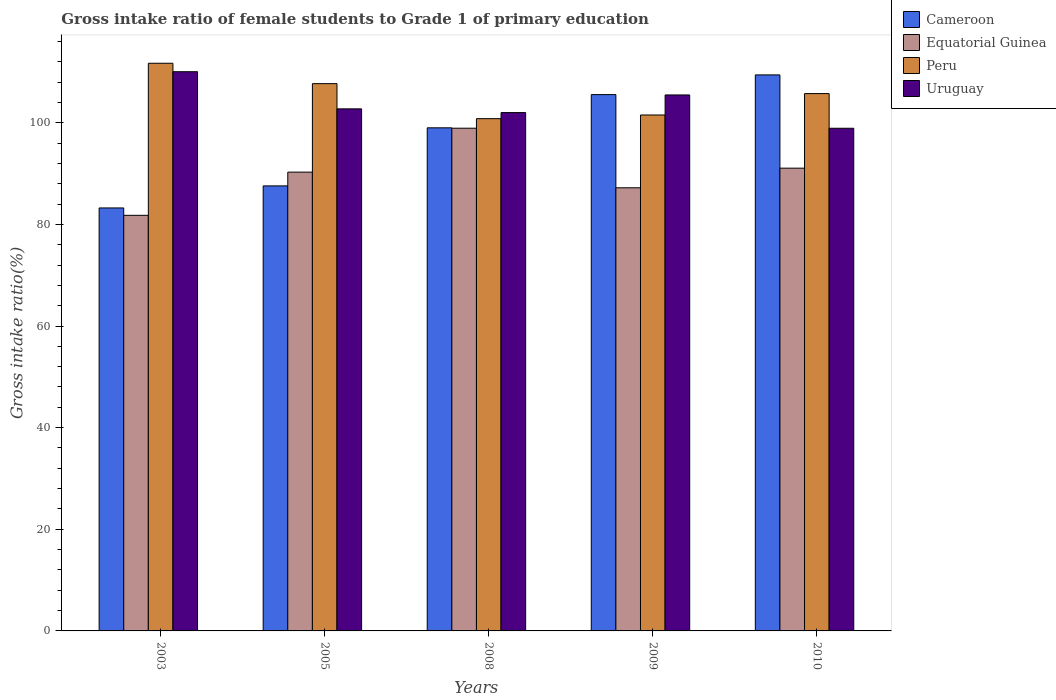How many different coloured bars are there?
Your answer should be compact. 4. How many groups of bars are there?
Provide a short and direct response. 5. Are the number of bars on each tick of the X-axis equal?
Ensure brevity in your answer.  Yes. What is the gross intake ratio in Peru in 2010?
Your response must be concise. 105.74. Across all years, what is the maximum gross intake ratio in Equatorial Guinea?
Offer a terse response. 98.92. Across all years, what is the minimum gross intake ratio in Uruguay?
Keep it short and to the point. 98.91. What is the total gross intake ratio in Uruguay in the graph?
Your response must be concise. 519.15. What is the difference between the gross intake ratio in Cameroon in 2009 and that in 2010?
Your answer should be compact. -3.88. What is the difference between the gross intake ratio in Equatorial Guinea in 2008 and the gross intake ratio in Peru in 2009?
Ensure brevity in your answer.  -2.6. What is the average gross intake ratio in Uruguay per year?
Offer a very short reply. 103.83. In the year 2003, what is the difference between the gross intake ratio in Cameroon and gross intake ratio in Peru?
Provide a short and direct response. -28.47. What is the ratio of the gross intake ratio in Uruguay in 2009 to that in 2010?
Provide a succinct answer. 1.07. What is the difference between the highest and the second highest gross intake ratio in Uruguay?
Offer a terse response. 4.57. What is the difference between the highest and the lowest gross intake ratio in Equatorial Guinea?
Provide a short and direct response. 17.14. Is it the case that in every year, the sum of the gross intake ratio in Uruguay and gross intake ratio in Peru is greater than the sum of gross intake ratio in Cameroon and gross intake ratio in Equatorial Guinea?
Offer a very short reply. Yes. What does the 3rd bar from the left in 2005 represents?
Provide a short and direct response. Peru. What does the 3rd bar from the right in 2005 represents?
Provide a succinct answer. Equatorial Guinea. Is it the case that in every year, the sum of the gross intake ratio in Equatorial Guinea and gross intake ratio in Cameroon is greater than the gross intake ratio in Peru?
Offer a very short reply. Yes. How many bars are there?
Offer a terse response. 20. Are all the bars in the graph horizontal?
Provide a short and direct response. No. Are the values on the major ticks of Y-axis written in scientific E-notation?
Make the answer very short. No. Does the graph contain grids?
Make the answer very short. No. How are the legend labels stacked?
Offer a very short reply. Vertical. What is the title of the graph?
Your response must be concise. Gross intake ratio of female students to Grade 1 of primary education. What is the label or title of the Y-axis?
Your answer should be compact. Gross intake ratio(%). What is the Gross intake ratio(%) in Cameroon in 2003?
Provide a succinct answer. 83.23. What is the Gross intake ratio(%) in Equatorial Guinea in 2003?
Make the answer very short. 81.78. What is the Gross intake ratio(%) in Peru in 2003?
Provide a short and direct response. 111.7. What is the Gross intake ratio(%) of Uruguay in 2003?
Your answer should be very brief. 110.04. What is the Gross intake ratio(%) in Cameroon in 2005?
Offer a terse response. 87.57. What is the Gross intake ratio(%) in Equatorial Guinea in 2005?
Your response must be concise. 90.28. What is the Gross intake ratio(%) of Peru in 2005?
Keep it short and to the point. 107.69. What is the Gross intake ratio(%) of Uruguay in 2005?
Provide a short and direct response. 102.73. What is the Gross intake ratio(%) in Cameroon in 2008?
Your response must be concise. 99. What is the Gross intake ratio(%) of Equatorial Guinea in 2008?
Offer a terse response. 98.92. What is the Gross intake ratio(%) of Peru in 2008?
Your answer should be compact. 100.8. What is the Gross intake ratio(%) of Uruguay in 2008?
Your response must be concise. 102. What is the Gross intake ratio(%) in Cameroon in 2009?
Your answer should be very brief. 105.54. What is the Gross intake ratio(%) of Equatorial Guinea in 2009?
Provide a succinct answer. 87.2. What is the Gross intake ratio(%) in Peru in 2009?
Give a very brief answer. 101.52. What is the Gross intake ratio(%) in Uruguay in 2009?
Keep it short and to the point. 105.47. What is the Gross intake ratio(%) of Cameroon in 2010?
Provide a succinct answer. 109.41. What is the Gross intake ratio(%) of Equatorial Guinea in 2010?
Offer a terse response. 91.06. What is the Gross intake ratio(%) of Peru in 2010?
Provide a succinct answer. 105.74. What is the Gross intake ratio(%) of Uruguay in 2010?
Keep it short and to the point. 98.91. Across all years, what is the maximum Gross intake ratio(%) of Cameroon?
Offer a very short reply. 109.41. Across all years, what is the maximum Gross intake ratio(%) of Equatorial Guinea?
Your answer should be very brief. 98.92. Across all years, what is the maximum Gross intake ratio(%) of Peru?
Offer a terse response. 111.7. Across all years, what is the maximum Gross intake ratio(%) in Uruguay?
Your answer should be very brief. 110.04. Across all years, what is the minimum Gross intake ratio(%) in Cameroon?
Your answer should be very brief. 83.23. Across all years, what is the minimum Gross intake ratio(%) in Equatorial Guinea?
Give a very brief answer. 81.78. Across all years, what is the minimum Gross intake ratio(%) in Peru?
Offer a very short reply. 100.8. Across all years, what is the minimum Gross intake ratio(%) in Uruguay?
Your answer should be very brief. 98.91. What is the total Gross intake ratio(%) of Cameroon in the graph?
Ensure brevity in your answer.  484.76. What is the total Gross intake ratio(%) in Equatorial Guinea in the graph?
Your answer should be very brief. 449.25. What is the total Gross intake ratio(%) of Peru in the graph?
Provide a succinct answer. 527.46. What is the total Gross intake ratio(%) in Uruguay in the graph?
Your answer should be very brief. 519.15. What is the difference between the Gross intake ratio(%) in Cameroon in 2003 and that in 2005?
Make the answer very short. -4.34. What is the difference between the Gross intake ratio(%) in Equatorial Guinea in 2003 and that in 2005?
Make the answer very short. -8.5. What is the difference between the Gross intake ratio(%) in Peru in 2003 and that in 2005?
Your answer should be compact. 4.01. What is the difference between the Gross intake ratio(%) in Uruguay in 2003 and that in 2005?
Keep it short and to the point. 7.31. What is the difference between the Gross intake ratio(%) of Cameroon in 2003 and that in 2008?
Provide a succinct answer. -15.77. What is the difference between the Gross intake ratio(%) of Equatorial Guinea in 2003 and that in 2008?
Offer a very short reply. -17.14. What is the difference between the Gross intake ratio(%) in Peru in 2003 and that in 2008?
Make the answer very short. 10.9. What is the difference between the Gross intake ratio(%) in Uruguay in 2003 and that in 2008?
Provide a succinct answer. 8.04. What is the difference between the Gross intake ratio(%) in Cameroon in 2003 and that in 2009?
Keep it short and to the point. -22.3. What is the difference between the Gross intake ratio(%) in Equatorial Guinea in 2003 and that in 2009?
Provide a succinct answer. -5.42. What is the difference between the Gross intake ratio(%) in Peru in 2003 and that in 2009?
Keep it short and to the point. 10.18. What is the difference between the Gross intake ratio(%) of Uruguay in 2003 and that in 2009?
Provide a succinct answer. 4.57. What is the difference between the Gross intake ratio(%) of Cameroon in 2003 and that in 2010?
Provide a short and direct response. -26.18. What is the difference between the Gross intake ratio(%) in Equatorial Guinea in 2003 and that in 2010?
Your response must be concise. -9.28. What is the difference between the Gross intake ratio(%) of Peru in 2003 and that in 2010?
Your answer should be compact. 5.97. What is the difference between the Gross intake ratio(%) in Uruguay in 2003 and that in 2010?
Your answer should be very brief. 11.13. What is the difference between the Gross intake ratio(%) in Cameroon in 2005 and that in 2008?
Your answer should be compact. -11.43. What is the difference between the Gross intake ratio(%) of Equatorial Guinea in 2005 and that in 2008?
Offer a terse response. -8.64. What is the difference between the Gross intake ratio(%) in Peru in 2005 and that in 2008?
Your answer should be very brief. 6.89. What is the difference between the Gross intake ratio(%) of Uruguay in 2005 and that in 2008?
Provide a succinct answer. 0.73. What is the difference between the Gross intake ratio(%) of Cameroon in 2005 and that in 2009?
Provide a succinct answer. -17.97. What is the difference between the Gross intake ratio(%) in Equatorial Guinea in 2005 and that in 2009?
Your response must be concise. 3.08. What is the difference between the Gross intake ratio(%) of Peru in 2005 and that in 2009?
Provide a short and direct response. 6.17. What is the difference between the Gross intake ratio(%) of Uruguay in 2005 and that in 2009?
Keep it short and to the point. -2.74. What is the difference between the Gross intake ratio(%) of Cameroon in 2005 and that in 2010?
Offer a very short reply. -21.84. What is the difference between the Gross intake ratio(%) in Equatorial Guinea in 2005 and that in 2010?
Give a very brief answer. -0.78. What is the difference between the Gross intake ratio(%) of Peru in 2005 and that in 2010?
Offer a terse response. 1.96. What is the difference between the Gross intake ratio(%) in Uruguay in 2005 and that in 2010?
Give a very brief answer. 3.82. What is the difference between the Gross intake ratio(%) of Cameroon in 2008 and that in 2009?
Make the answer very short. -6.54. What is the difference between the Gross intake ratio(%) in Equatorial Guinea in 2008 and that in 2009?
Make the answer very short. 11.72. What is the difference between the Gross intake ratio(%) in Peru in 2008 and that in 2009?
Keep it short and to the point. -0.72. What is the difference between the Gross intake ratio(%) in Uruguay in 2008 and that in 2009?
Provide a short and direct response. -3.47. What is the difference between the Gross intake ratio(%) in Cameroon in 2008 and that in 2010?
Offer a very short reply. -10.41. What is the difference between the Gross intake ratio(%) in Equatorial Guinea in 2008 and that in 2010?
Your response must be concise. 7.86. What is the difference between the Gross intake ratio(%) in Peru in 2008 and that in 2010?
Provide a succinct answer. -4.93. What is the difference between the Gross intake ratio(%) in Uruguay in 2008 and that in 2010?
Provide a short and direct response. 3.08. What is the difference between the Gross intake ratio(%) of Cameroon in 2009 and that in 2010?
Ensure brevity in your answer.  -3.88. What is the difference between the Gross intake ratio(%) of Equatorial Guinea in 2009 and that in 2010?
Make the answer very short. -3.86. What is the difference between the Gross intake ratio(%) of Peru in 2009 and that in 2010?
Make the answer very short. -4.21. What is the difference between the Gross intake ratio(%) in Uruguay in 2009 and that in 2010?
Keep it short and to the point. 6.56. What is the difference between the Gross intake ratio(%) of Cameroon in 2003 and the Gross intake ratio(%) of Equatorial Guinea in 2005?
Keep it short and to the point. -7.05. What is the difference between the Gross intake ratio(%) in Cameroon in 2003 and the Gross intake ratio(%) in Peru in 2005?
Your answer should be very brief. -24.46. What is the difference between the Gross intake ratio(%) of Cameroon in 2003 and the Gross intake ratio(%) of Uruguay in 2005?
Ensure brevity in your answer.  -19.5. What is the difference between the Gross intake ratio(%) of Equatorial Guinea in 2003 and the Gross intake ratio(%) of Peru in 2005?
Offer a terse response. -25.91. What is the difference between the Gross intake ratio(%) of Equatorial Guinea in 2003 and the Gross intake ratio(%) of Uruguay in 2005?
Give a very brief answer. -20.95. What is the difference between the Gross intake ratio(%) of Peru in 2003 and the Gross intake ratio(%) of Uruguay in 2005?
Your answer should be very brief. 8.97. What is the difference between the Gross intake ratio(%) in Cameroon in 2003 and the Gross intake ratio(%) in Equatorial Guinea in 2008?
Your answer should be very brief. -15.69. What is the difference between the Gross intake ratio(%) in Cameroon in 2003 and the Gross intake ratio(%) in Peru in 2008?
Your answer should be very brief. -17.57. What is the difference between the Gross intake ratio(%) in Cameroon in 2003 and the Gross intake ratio(%) in Uruguay in 2008?
Your answer should be very brief. -18.76. What is the difference between the Gross intake ratio(%) of Equatorial Guinea in 2003 and the Gross intake ratio(%) of Peru in 2008?
Ensure brevity in your answer.  -19.02. What is the difference between the Gross intake ratio(%) of Equatorial Guinea in 2003 and the Gross intake ratio(%) of Uruguay in 2008?
Provide a succinct answer. -20.22. What is the difference between the Gross intake ratio(%) in Peru in 2003 and the Gross intake ratio(%) in Uruguay in 2008?
Provide a succinct answer. 9.71. What is the difference between the Gross intake ratio(%) in Cameroon in 2003 and the Gross intake ratio(%) in Equatorial Guinea in 2009?
Keep it short and to the point. -3.97. What is the difference between the Gross intake ratio(%) of Cameroon in 2003 and the Gross intake ratio(%) of Peru in 2009?
Your response must be concise. -18.29. What is the difference between the Gross intake ratio(%) of Cameroon in 2003 and the Gross intake ratio(%) of Uruguay in 2009?
Offer a very short reply. -22.24. What is the difference between the Gross intake ratio(%) of Equatorial Guinea in 2003 and the Gross intake ratio(%) of Peru in 2009?
Your response must be concise. -19.74. What is the difference between the Gross intake ratio(%) of Equatorial Guinea in 2003 and the Gross intake ratio(%) of Uruguay in 2009?
Offer a very short reply. -23.69. What is the difference between the Gross intake ratio(%) of Peru in 2003 and the Gross intake ratio(%) of Uruguay in 2009?
Your answer should be compact. 6.23. What is the difference between the Gross intake ratio(%) in Cameroon in 2003 and the Gross intake ratio(%) in Equatorial Guinea in 2010?
Provide a short and direct response. -7.83. What is the difference between the Gross intake ratio(%) of Cameroon in 2003 and the Gross intake ratio(%) of Peru in 2010?
Your response must be concise. -22.5. What is the difference between the Gross intake ratio(%) of Cameroon in 2003 and the Gross intake ratio(%) of Uruguay in 2010?
Provide a succinct answer. -15.68. What is the difference between the Gross intake ratio(%) in Equatorial Guinea in 2003 and the Gross intake ratio(%) in Peru in 2010?
Ensure brevity in your answer.  -23.95. What is the difference between the Gross intake ratio(%) in Equatorial Guinea in 2003 and the Gross intake ratio(%) in Uruguay in 2010?
Provide a short and direct response. -17.13. What is the difference between the Gross intake ratio(%) of Peru in 2003 and the Gross intake ratio(%) of Uruguay in 2010?
Offer a very short reply. 12.79. What is the difference between the Gross intake ratio(%) in Cameroon in 2005 and the Gross intake ratio(%) in Equatorial Guinea in 2008?
Provide a succinct answer. -11.35. What is the difference between the Gross intake ratio(%) of Cameroon in 2005 and the Gross intake ratio(%) of Peru in 2008?
Provide a short and direct response. -13.23. What is the difference between the Gross intake ratio(%) in Cameroon in 2005 and the Gross intake ratio(%) in Uruguay in 2008?
Offer a very short reply. -14.43. What is the difference between the Gross intake ratio(%) in Equatorial Guinea in 2005 and the Gross intake ratio(%) in Peru in 2008?
Give a very brief answer. -10.52. What is the difference between the Gross intake ratio(%) in Equatorial Guinea in 2005 and the Gross intake ratio(%) in Uruguay in 2008?
Your answer should be very brief. -11.72. What is the difference between the Gross intake ratio(%) of Peru in 2005 and the Gross intake ratio(%) of Uruguay in 2008?
Keep it short and to the point. 5.7. What is the difference between the Gross intake ratio(%) in Cameroon in 2005 and the Gross intake ratio(%) in Equatorial Guinea in 2009?
Your response must be concise. 0.37. What is the difference between the Gross intake ratio(%) of Cameroon in 2005 and the Gross intake ratio(%) of Peru in 2009?
Provide a succinct answer. -13.95. What is the difference between the Gross intake ratio(%) of Cameroon in 2005 and the Gross intake ratio(%) of Uruguay in 2009?
Your answer should be very brief. -17.9. What is the difference between the Gross intake ratio(%) in Equatorial Guinea in 2005 and the Gross intake ratio(%) in Peru in 2009?
Your answer should be compact. -11.24. What is the difference between the Gross intake ratio(%) of Equatorial Guinea in 2005 and the Gross intake ratio(%) of Uruguay in 2009?
Offer a terse response. -15.19. What is the difference between the Gross intake ratio(%) of Peru in 2005 and the Gross intake ratio(%) of Uruguay in 2009?
Your response must be concise. 2.22. What is the difference between the Gross intake ratio(%) of Cameroon in 2005 and the Gross intake ratio(%) of Equatorial Guinea in 2010?
Give a very brief answer. -3.49. What is the difference between the Gross intake ratio(%) in Cameroon in 2005 and the Gross intake ratio(%) in Peru in 2010?
Offer a terse response. -18.16. What is the difference between the Gross intake ratio(%) of Cameroon in 2005 and the Gross intake ratio(%) of Uruguay in 2010?
Provide a short and direct response. -11.34. What is the difference between the Gross intake ratio(%) of Equatorial Guinea in 2005 and the Gross intake ratio(%) of Peru in 2010?
Offer a very short reply. -15.46. What is the difference between the Gross intake ratio(%) in Equatorial Guinea in 2005 and the Gross intake ratio(%) in Uruguay in 2010?
Provide a succinct answer. -8.63. What is the difference between the Gross intake ratio(%) of Peru in 2005 and the Gross intake ratio(%) of Uruguay in 2010?
Your answer should be compact. 8.78. What is the difference between the Gross intake ratio(%) of Cameroon in 2008 and the Gross intake ratio(%) of Equatorial Guinea in 2009?
Your response must be concise. 11.8. What is the difference between the Gross intake ratio(%) in Cameroon in 2008 and the Gross intake ratio(%) in Peru in 2009?
Give a very brief answer. -2.52. What is the difference between the Gross intake ratio(%) of Cameroon in 2008 and the Gross intake ratio(%) of Uruguay in 2009?
Make the answer very short. -6.47. What is the difference between the Gross intake ratio(%) in Equatorial Guinea in 2008 and the Gross intake ratio(%) in Peru in 2009?
Give a very brief answer. -2.6. What is the difference between the Gross intake ratio(%) of Equatorial Guinea in 2008 and the Gross intake ratio(%) of Uruguay in 2009?
Give a very brief answer. -6.55. What is the difference between the Gross intake ratio(%) in Peru in 2008 and the Gross intake ratio(%) in Uruguay in 2009?
Make the answer very short. -4.67. What is the difference between the Gross intake ratio(%) of Cameroon in 2008 and the Gross intake ratio(%) of Equatorial Guinea in 2010?
Your response must be concise. 7.94. What is the difference between the Gross intake ratio(%) in Cameroon in 2008 and the Gross intake ratio(%) in Peru in 2010?
Give a very brief answer. -6.73. What is the difference between the Gross intake ratio(%) in Cameroon in 2008 and the Gross intake ratio(%) in Uruguay in 2010?
Keep it short and to the point. 0.09. What is the difference between the Gross intake ratio(%) in Equatorial Guinea in 2008 and the Gross intake ratio(%) in Peru in 2010?
Your answer should be very brief. -6.81. What is the difference between the Gross intake ratio(%) of Equatorial Guinea in 2008 and the Gross intake ratio(%) of Uruguay in 2010?
Keep it short and to the point. 0.01. What is the difference between the Gross intake ratio(%) in Peru in 2008 and the Gross intake ratio(%) in Uruguay in 2010?
Ensure brevity in your answer.  1.89. What is the difference between the Gross intake ratio(%) in Cameroon in 2009 and the Gross intake ratio(%) in Equatorial Guinea in 2010?
Offer a terse response. 14.48. What is the difference between the Gross intake ratio(%) of Cameroon in 2009 and the Gross intake ratio(%) of Peru in 2010?
Provide a short and direct response. -0.2. What is the difference between the Gross intake ratio(%) of Cameroon in 2009 and the Gross intake ratio(%) of Uruguay in 2010?
Give a very brief answer. 6.63. What is the difference between the Gross intake ratio(%) of Equatorial Guinea in 2009 and the Gross intake ratio(%) of Peru in 2010?
Offer a very short reply. -18.54. What is the difference between the Gross intake ratio(%) in Equatorial Guinea in 2009 and the Gross intake ratio(%) in Uruguay in 2010?
Give a very brief answer. -11.71. What is the difference between the Gross intake ratio(%) of Peru in 2009 and the Gross intake ratio(%) of Uruguay in 2010?
Provide a succinct answer. 2.61. What is the average Gross intake ratio(%) in Cameroon per year?
Give a very brief answer. 96.95. What is the average Gross intake ratio(%) of Equatorial Guinea per year?
Your answer should be compact. 89.85. What is the average Gross intake ratio(%) in Peru per year?
Provide a succinct answer. 105.49. What is the average Gross intake ratio(%) in Uruguay per year?
Provide a succinct answer. 103.83. In the year 2003, what is the difference between the Gross intake ratio(%) in Cameroon and Gross intake ratio(%) in Equatorial Guinea?
Offer a terse response. 1.45. In the year 2003, what is the difference between the Gross intake ratio(%) in Cameroon and Gross intake ratio(%) in Peru?
Offer a very short reply. -28.47. In the year 2003, what is the difference between the Gross intake ratio(%) in Cameroon and Gross intake ratio(%) in Uruguay?
Ensure brevity in your answer.  -26.81. In the year 2003, what is the difference between the Gross intake ratio(%) of Equatorial Guinea and Gross intake ratio(%) of Peru?
Your answer should be very brief. -29.92. In the year 2003, what is the difference between the Gross intake ratio(%) in Equatorial Guinea and Gross intake ratio(%) in Uruguay?
Offer a terse response. -28.26. In the year 2003, what is the difference between the Gross intake ratio(%) of Peru and Gross intake ratio(%) of Uruguay?
Ensure brevity in your answer.  1.66. In the year 2005, what is the difference between the Gross intake ratio(%) of Cameroon and Gross intake ratio(%) of Equatorial Guinea?
Your answer should be very brief. -2.71. In the year 2005, what is the difference between the Gross intake ratio(%) in Cameroon and Gross intake ratio(%) in Peru?
Give a very brief answer. -20.12. In the year 2005, what is the difference between the Gross intake ratio(%) in Cameroon and Gross intake ratio(%) in Uruguay?
Offer a terse response. -15.16. In the year 2005, what is the difference between the Gross intake ratio(%) of Equatorial Guinea and Gross intake ratio(%) of Peru?
Your answer should be compact. -17.41. In the year 2005, what is the difference between the Gross intake ratio(%) of Equatorial Guinea and Gross intake ratio(%) of Uruguay?
Offer a terse response. -12.45. In the year 2005, what is the difference between the Gross intake ratio(%) in Peru and Gross intake ratio(%) in Uruguay?
Offer a terse response. 4.96. In the year 2008, what is the difference between the Gross intake ratio(%) of Cameroon and Gross intake ratio(%) of Equatorial Guinea?
Offer a very short reply. 0.08. In the year 2008, what is the difference between the Gross intake ratio(%) of Cameroon and Gross intake ratio(%) of Peru?
Your answer should be very brief. -1.8. In the year 2008, what is the difference between the Gross intake ratio(%) of Cameroon and Gross intake ratio(%) of Uruguay?
Offer a terse response. -3. In the year 2008, what is the difference between the Gross intake ratio(%) of Equatorial Guinea and Gross intake ratio(%) of Peru?
Provide a succinct answer. -1.88. In the year 2008, what is the difference between the Gross intake ratio(%) of Equatorial Guinea and Gross intake ratio(%) of Uruguay?
Your answer should be very brief. -3.07. In the year 2008, what is the difference between the Gross intake ratio(%) in Peru and Gross intake ratio(%) in Uruguay?
Your answer should be compact. -1.2. In the year 2009, what is the difference between the Gross intake ratio(%) in Cameroon and Gross intake ratio(%) in Equatorial Guinea?
Your response must be concise. 18.34. In the year 2009, what is the difference between the Gross intake ratio(%) in Cameroon and Gross intake ratio(%) in Peru?
Give a very brief answer. 4.01. In the year 2009, what is the difference between the Gross intake ratio(%) of Cameroon and Gross intake ratio(%) of Uruguay?
Your answer should be compact. 0.07. In the year 2009, what is the difference between the Gross intake ratio(%) in Equatorial Guinea and Gross intake ratio(%) in Peru?
Give a very brief answer. -14.32. In the year 2009, what is the difference between the Gross intake ratio(%) of Equatorial Guinea and Gross intake ratio(%) of Uruguay?
Make the answer very short. -18.27. In the year 2009, what is the difference between the Gross intake ratio(%) in Peru and Gross intake ratio(%) in Uruguay?
Provide a succinct answer. -3.95. In the year 2010, what is the difference between the Gross intake ratio(%) of Cameroon and Gross intake ratio(%) of Equatorial Guinea?
Give a very brief answer. 18.35. In the year 2010, what is the difference between the Gross intake ratio(%) of Cameroon and Gross intake ratio(%) of Peru?
Ensure brevity in your answer.  3.68. In the year 2010, what is the difference between the Gross intake ratio(%) of Cameroon and Gross intake ratio(%) of Uruguay?
Provide a succinct answer. 10.5. In the year 2010, what is the difference between the Gross intake ratio(%) of Equatorial Guinea and Gross intake ratio(%) of Peru?
Make the answer very short. -14.67. In the year 2010, what is the difference between the Gross intake ratio(%) in Equatorial Guinea and Gross intake ratio(%) in Uruguay?
Your response must be concise. -7.85. In the year 2010, what is the difference between the Gross intake ratio(%) of Peru and Gross intake ratio(%) of Uruguay?
Provide a short and direct response. 6.82. What is the ratio of the Gross intake ratio(%) of Cameroon in 2003 to that in 2005?
Give a very brief answer. 0.95. What is the ratio of the Gross intake ratio(%) of Equatorial Guinea in 2003 to that in 2005?
Your response must be concise. 0.91. What is the ratio of the Gross intake ratio(%) of Peru in 2003 to that in 2005?
Provide a short and direct response. 1.04. What is the ratio of the Gross intake ratio(%) of Uruguay in 2003 to that in 2005?
Your response must be concise. 1.07. What is the ratio of the Gross intake ratio(%) in Cameroon in 2003 to that in 2008?
Provide a succinct answer. 0.84. What is the ratio of the Gross intake ratio(%) in Equatorial Guinea in 2003 to that in 2008?
Provide a short and direct response. 0.83. What is the ratio of the Gross intake ratio(%) of Peru in 2003 to that in 2008?
Ensure brevity in your answer.  1.11. What is the ratio of the Gross intake ratio(%) in Uruguay in 2003 to that in 2008?
Ensure brevity in your answer.  1.08. What is the ratio of the Gross intake ratio(%) of Cameroon in 2003 to that in 2009?
Your response must be concise. 0.79. What is the ratio of the Gross intake ratio(%) in Equatorial Guinea in 2003 to that in 2009?
Make the answer very short. 0.94. What is the ratio of the Gross intake ratio(%) of Peru in 2003 to that in 2009?
Make the answer very short. 1.1. What is the ratio of the Gross intake ratio(%) in Uruguay in 2003 to that in 2009?
Make the answer very short. 1.04. What is the ratio of the Gross intake ratio(%) in Cameroon in 2003 to that in 2010?
Provide a short and direct response. 0.76. What is the ratio of the Gross intake ratio(%) of Equatorial Guinea in 2003 to that in 2010?
Offer a very short reply. 0.9. What is the ratio of the Gross intake ratio(%) in Peru in 2003 to that in 2010?
Offer a terse response. 1.06. What is the ratio of the Gross intake ratio(%) of Uruguay in 2003 to that in 2010?
Your answer should be compact. 1.11. What is the ratio of the Gross intake ratio(%) in Cameroon in 2005 to that in 2008?
Provide a short and direct response. 0.88. What is the ratio of the Gross intake ratio(%) of Equatorial Guinea in 2005 to that in 2008?
Your answer should be compact. 0.91. What is the ratio of the Gross intake ratio(%) of Peru in 2005 to that in 2008?
Offer a very short reply. 1.07. What is the ratio of the Gross intake ratio(%) of Cameroon in 2005 to that in 2009?
Provide a succinct answer. 0.83. What is the ratio of the Gross intake ratio(%) of Equatorial Guinea in 2005 to that in 2009?
Offer a terse response. 1.04. What is the ratio of the Gross intake ratio(%) in Peru in 2005 to that in 2009?
Offer a terse response. 1.06. What is the ratio of the Gross intake ratio(%) in Cameroon in 2005 to that in 2010?
Provide a short and direct response. 0.8. What is the ratio of the Gross intake ratio(%) of Equatorial Guinea in 2005 to that in 2010?
Make the answer very short. 0.99. What is the ratio of the Gross intake ratio(%) in Peru in 2005 to that in 2010?
Your response must be concise. 1.02. What is the ratio of the Gross intake ratio(%) of Uruguay in 2005 to that in 2010?
Ensure brevity in your answer.  1.04. What is the ratio of the Gross intake ratio(%) in Cameroon in 2008 to that in 2009?
Your answer should be very brief. 0.94. What is the ratio of the Gross intake ratio(%) in Equatorial Guinea in 2008 to that in 2009?
Your answer should be very brief. 1.13. What is the ratio of the Gross intake ratio(%) of Peru in 2008 to that in 2009?
Your answer should be compact. 0.99. What is the ratio of the Gross intake ratio(%) of Uruguay in 2008 to that in 2009?
Offer a terse response. 0.97. What is the ratio of the Gross intake ratio(%) of Cameroon in 2008 to that in 2010?
Your response must be concise. 0.9. What is the ratio of the Gross intake ratio(%) of Equatorial Guinea in 2008 to that in 2010?
Ensure brevity in your answer.  1.09. What is the ratio of the Gross intake ratio(%) of Peru in 2008 to that in 2010?
Give a very brief answer. 0.95. What is the ratio of the Gross intake ratio(%) of Uruguay in 2008 to that in 2010?
Your answer should be compact. 1.03. What is the ratio of the Gross intake ratio(%) in Cameroon in 2009 to that in 2010?
Provide a short and direct response. 0.96. What is the ratio of the Gross intake ratio(%) of Equatorial Guinea in 2009 to that in 2010?
Ensure brevity in your answer.  0.96. What is the ratio of the Gross intake ratio(%) of Peru in 2009 to that in 2010?
Give a very brief answer. 0.96. What is the ratio of the Gross intake ratio(%) in Uruguay in 2009 to that in 2010?
Make the answer very short. 1.07. What is the difference between the highest and the second highest Gross intake ratio(%) in Cameroon?
Your response must be concise. 3.88. What is the difference between the highest and the second highest Gross intake ratio(%) in Equatorial Guinea?
Offer a very short reply. 7.86. What is the difference between the highest and the second highest Gross intake ratio(%) in Peru?
Make the answer very short. 4.01. What is the difference between the highest and the second highest Gross intake ratio(%) in Uruguay?
Offer a very short reply. 4.57. What is the difference between the highest and the lowest Gross intake ratio(%) in Cameroon?
Provide a short and direct response. 26.18. What is the difference between the highest and the lowest Gross intake ratio(%) of Equatorial Guinea?
Provide a short and direct response. 17.14. What is the difference between the highest and the lowest Gross intake ratio(%) in Peru?
Give a very brief answer. 10.9. What is the difference between the highest and the lowest Gross intake ratio(%) of Uruguay?
Keep it short and to the point. 11.13. 